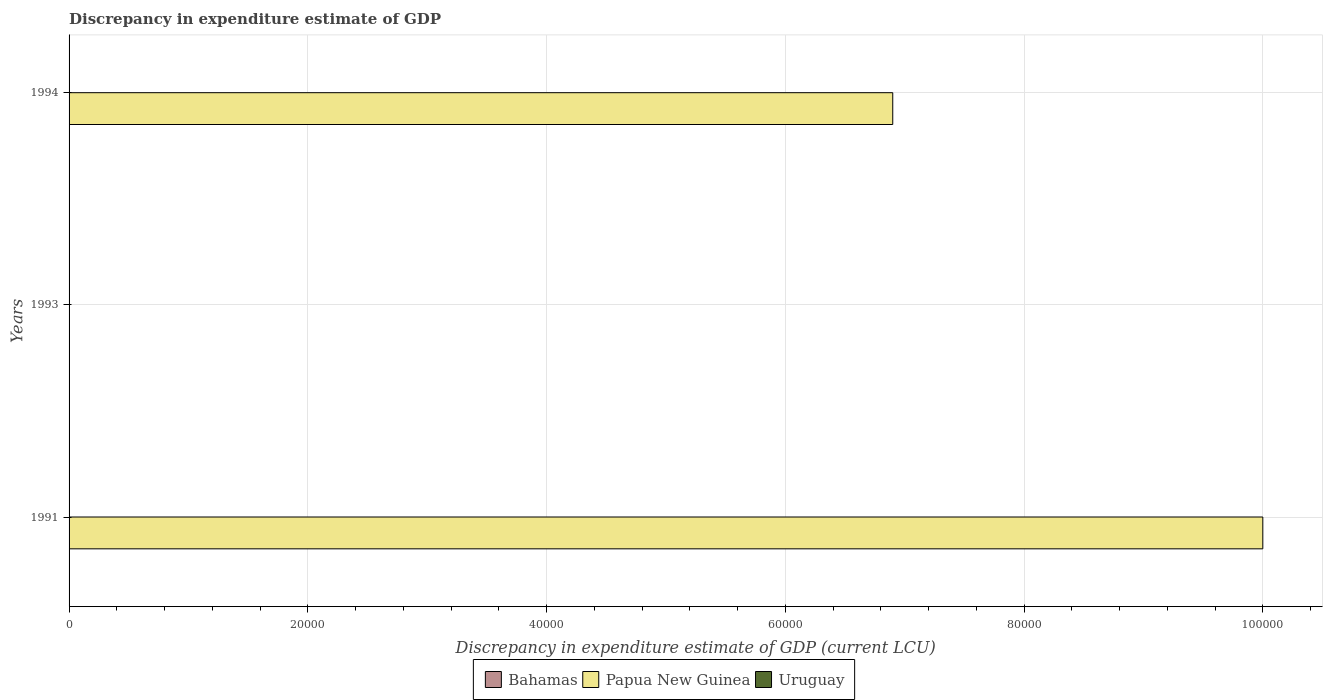How many different coloured bars are there?
Make the answer very short. 2. Are the number of bars per tick equal to the number of legend labels?
Keep it short and to the point. No. How many bars are there on the 2nd tick from the bottom?
Provide a succinct answer. 1. Across all years, what is the maximum discrepancy in expenditure estimate of GDP in Papua New Guinea?
Your answer should be compact. 1.00e+05. What is the total discrepancy in expenditure estimate of GDP in Bahamas in the graph?
Your answer should be compact. 0. What is the difference between the discrepancy in expenditure estimate of GDP in Papua New Guinea in 1991 and that in 1994?
Provide a short and direct response. 3.10e+04. What is the difference between the discrepancy in expenditure estimate of GDP in Uruguay in 1993 and the discrepancy in expenditure estimate of GDP in Papua New Guinea in 1994?
Offer a very short reply. -6.90e+04. What is the average discrepancy in expenditure estimate of GDP in Bahamas per year?
Provide a succinct answer. 0. In the year 1991, what is the difference between the discrepancy in expenditure estimate of GDP in Papua New Guinea and discrepancy in expenditure estimate of GDP in Uruguay?
Your answer should be compact. 1.00e+05. In how many years, is the discrepancy in expenditure estimate of GDP in Papua New Guinea greater than 28000 LCU?
Keep it short and to the point. 2. What is the ratio of the discrepancy in expenditure estimate of GDP in Uruguay in 1991 to that in 1993?
Your answer should be very brief. 0.4. In how many years, is the discrepancy in expenditure estimate of GDP in Bahamas greater than the average discrepancy in expenditure estimate of GDP in Bahamas taken over all years?
Provide a short and direct response. 0. Is the sum of the discrepancy in expenditure estimate of GDP in Papua New Guinea in 1991 and 1994 greater than the maximum discrepancy in expenditure estimate of GDP in Uruguay across all years?
Ensure brevity in your answer.  Yes. Is it the case that in every year, the sum of the discrepancy in expenditure estimate of GDP in Uruguay and discrepancy in expenditure estimate of GDP in Papua New Guinea is greater than the discrepancy in expenditure estimate of GDP in Bahamas?
Ensure brevity in your answer.  Yes. How many bars are there?
Provide a short and direct response. 4. What is the difference between two consecutive major ticks on the X-axis?
Your answer should be very brief. 2.00e+04. Does the graph contain grids?
Provide a short and direct response. Yes. How are the legend labels stacked?
Keep it short and to the point. Horizontal. What is the title of the graph?
Your answer should be compact. Discrepancy in expenditure estimate of GDP. Does "Indonesia" appear as one of the legend labels in the graph?
Your answer should be compact. No. What is the label or title of the X-axis?
Offer a terse response. Discrepancy in expenditure estimate of GDP (current LCU). What is the label or title of the Y-axis?
Your answer should be compact. Years. What is the Discrepancy in expenditure estimate of GDP (current LCU) in Uruguay in 1991?
Provide a succinct answer. 4e-6. What is the Discrepancy in expenditure estimate of GDP (current LCU) of Papua New Guinea in 1993?
Offer a very short reply. 0. What is the Discrepancy in expenditure estimate of GDP (current LCU) in Uruguay in 1993?
Give a very brief answer. 1e-5. What is the Discrepancy in expenditure estimate of GDP (current LCU) of Bahamas in 1994?
Your answer should be very brief. 0. What is the Discrepancy in expenditure estimate of GDP (current LCU) of Papua New Guinea in 1994?
Your answer should be compact. 6.90e+04. Across all years, what is the maximum Discrepancy in expenditure estimate of GDP (current LCU) of Uruguay?
Offer a terse response. 1e-5. What is the total Discrepancy in expenditure estimate of GDP (current LCU) of Papua New Guinea in the graph?
Keep it short and to the point. 1.69e+05. What is the total Discrepancy in expenditure estimate of GDP (current LCU) of Uruguay in the graph?
Provide a succinct answer. 0. What is the difference between the Discrepancy in expenditure estimate of GDP (current LCU) of Uruguay in 1991 and that in 1993?
Keep it short and to the point. -0. What is the difference between the Discrepancy in expenditure estimate of GDP (current LCU) of Papua New Guinea in 1991 and that in 1994?
Provide a succinct answer. 3.10e+04. What is the difference between the Discrepancy in expenditure estimate of GDP (current LCU) of Papua New Guinea in 1991 and the Discrepancy in expenditure estimate of GDP (current LCU) of Uruguay in 1993?
Your answer should be compact. 1.00e+05. What is the average Discrepancy in expenditure estimate of GDP (current LCU) of Papua New Guinea per year?
Make the answer very short. 5.63e+04. What is the average Discrepancy in expenditure estimate of GDP (current LCU) of Uruguay per year?
Your answer should be very brief. 0. In the year 1991, what is the difference between the Discrepancy in expenditure estimate of GDP (current LCU) of Papua New Guinea and Discrepancy in expenditure estimate of GDP (current LCU) of Uruguay?
Give a very brief answer. 1.00e+05. What is the ratio of the Discrepancy in expenditure estimate of GDP (current LCU) in Papua New Guinea in 1991 to that in 1994?
Ensure brevity in your answer.  1.45. What is the difference between the highest and the lowest Discrepancy in expenditure estimate of GDP (current LCU) of Uruguay?
Give a very brief answer. 0. 